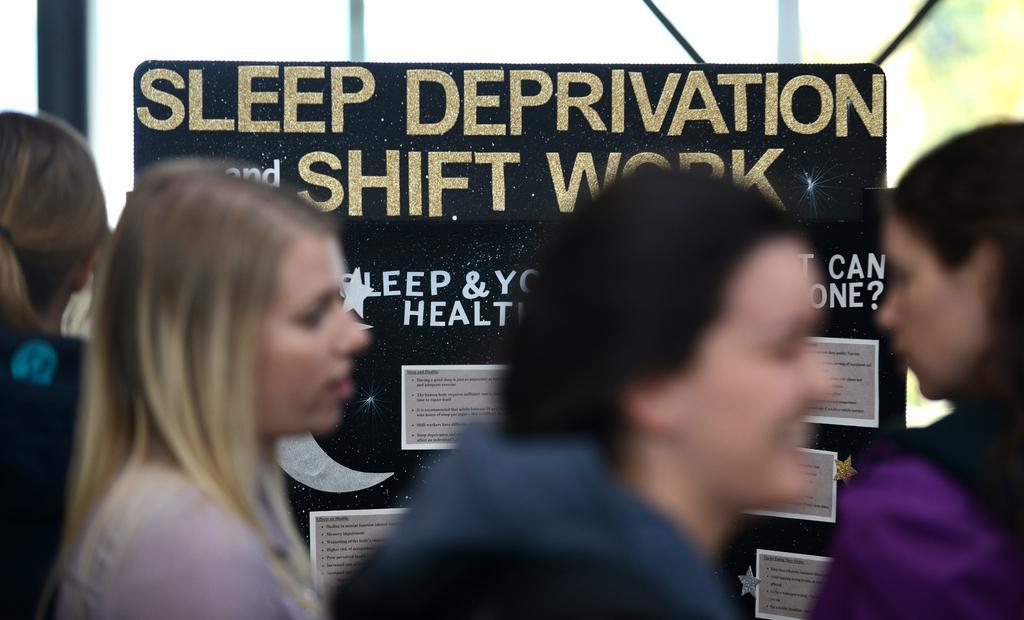How would you summarize this image in a sentence or two? In this image we can see four persons and a board, on the board, we can see some text and posters, in the background, we can see the poles. 